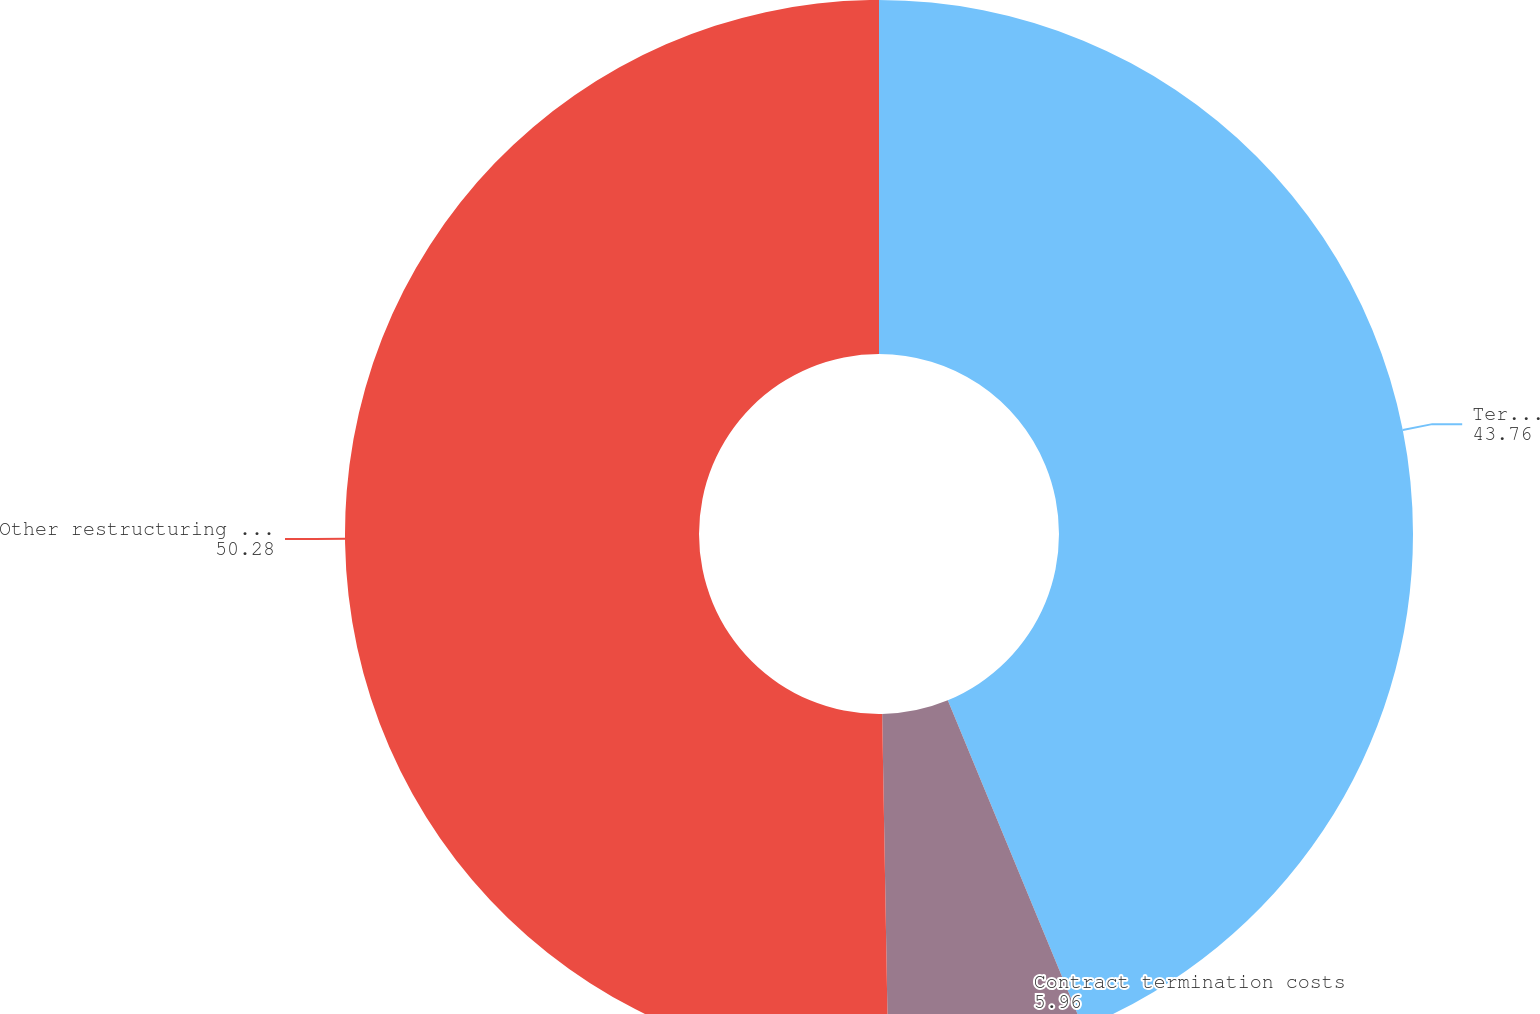Convert chart to OTSL. <chart><loc_0><loc_0><loc_500><loc_500><pie_chart><fcel>Termination benefits<fcel>Contract termination costs<fcel>Other restructuring costs<nl><fcel>43.76%<fcel>5.96%<fcel>50.28%<nl></chart> 